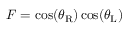Convert formula to latex. <formula><loc_0><loc_0><loc_500><loc_500>F = \cos ( \theta _ { R } ) \cos ( \theta _ { L } )</formula> 